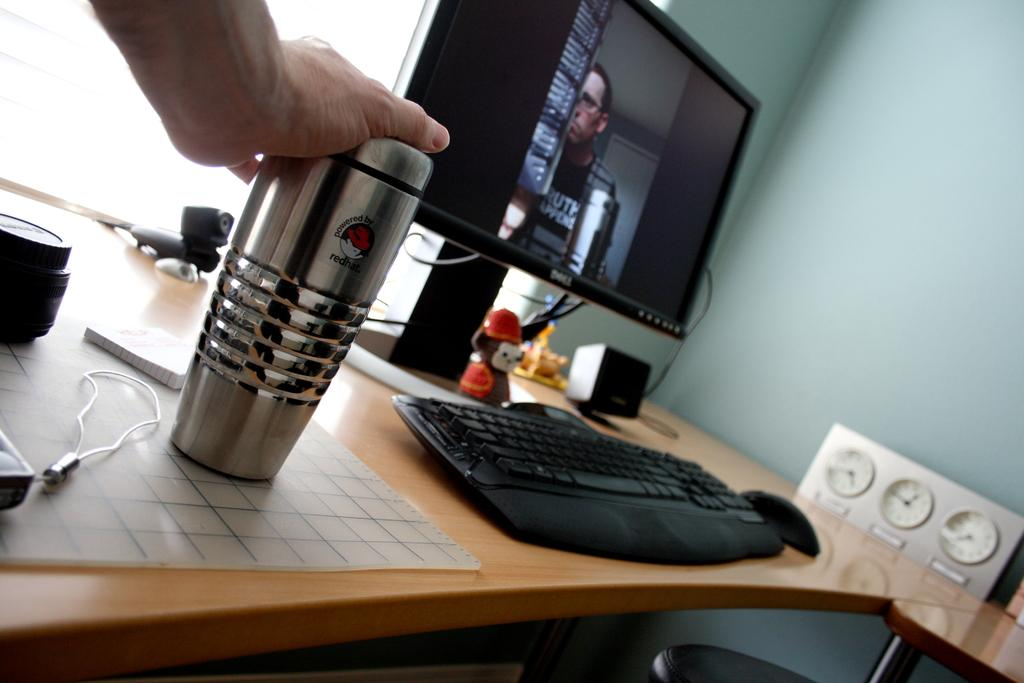What type of furniture is present in the image? There is a table in the image. What electronic device is on the table? There is a monitor on the table. What is used for typing on the monitor? There is a keyboard on the table. What type of beverage container is on the table? There is a glass on the table. What can be seen in the background of the image? There is a wall visible in the image. What type of government is depicted in the image? There is no depiction of a government in the image; it features a table with a monitor, keyboard, glass, and a wall in the background. 